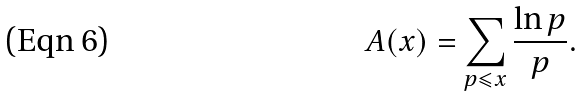<formula> <loc_0><loc_0><loc_500><loc_500>A ( x ) = \sum _ { p \leqslant x } \frac { \ln p } { p } .</formula> 